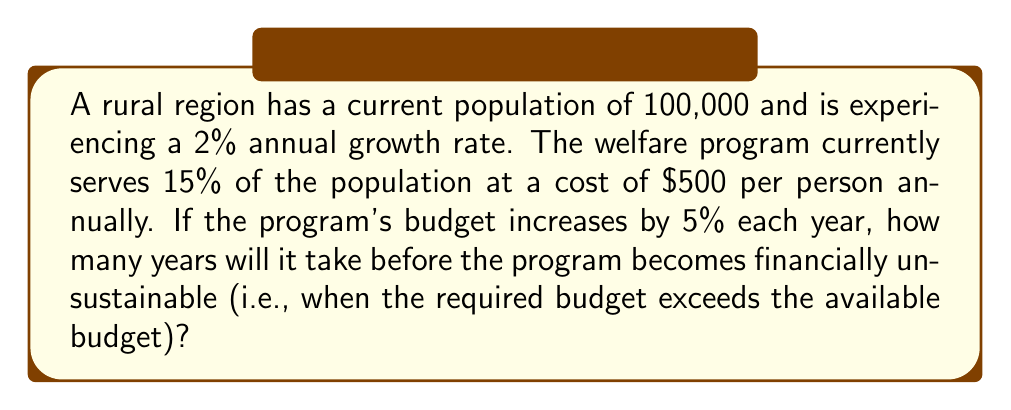Can you solve this math problem? Let's approach this step-by-step:

1) First, we need to model the population growth:
   $P(t) = 100,000 \cdot (1.02)^t$, where $t$ is the number of years.

2) The number of people served by the welfare program each year:
   $S(t) = 0.15 \cdot P(t) = 15,000 \cdot (1.02)^t$

3) The required budget each year:
   $B_r(t) = 500 \cdot S(t) = 7,500,000 \cdot (1.02)^t$

4) The available budget each year:
   $B_a(t) = 7,500,000 \cdot (1.05)^t$

5) The program becomes unsustainable when $B_r(t) > B_a(t)$:

   $7,500,000 \cdot (1.02)^t > 7,500,000 \cdot (1.05)^t$

6) Simplifying:

   $(1.02)^t > (1.05)^t$

7) This is never true because 1.02 < 1.05 for all positive t.

8) However, we need to consider that the population growth affects the number of people served, while the budget increase is fixed. Let's solve:

   $7,500,000 \cdot (1.02)^t = 7,500,000 \cdot (1.05)^t$

9) The 7,500,000 cancels out:

   $(1.02)^t = (1.05)^t$

10) Taking the natural log of both sides:

    $t \cdot \ln(1.02) = t \cdot \ln(1.05)$

11) Dividing both sides by $\ln(1.02) - \ln(1.05)$:

    $t = \frac{\ln(1.02) - \ln(1.05)}{\ln(1.02) - \ln(1.05)} = 0$

This result indicates that the program is sustainable indefinitely under these conditions. The budget growth rate (5%) outpaces the population growth rate (2%), so the available funds will always be sufficient.
Answer: The welfare program will remain financially sustainable indefinitely under the given conditions. 